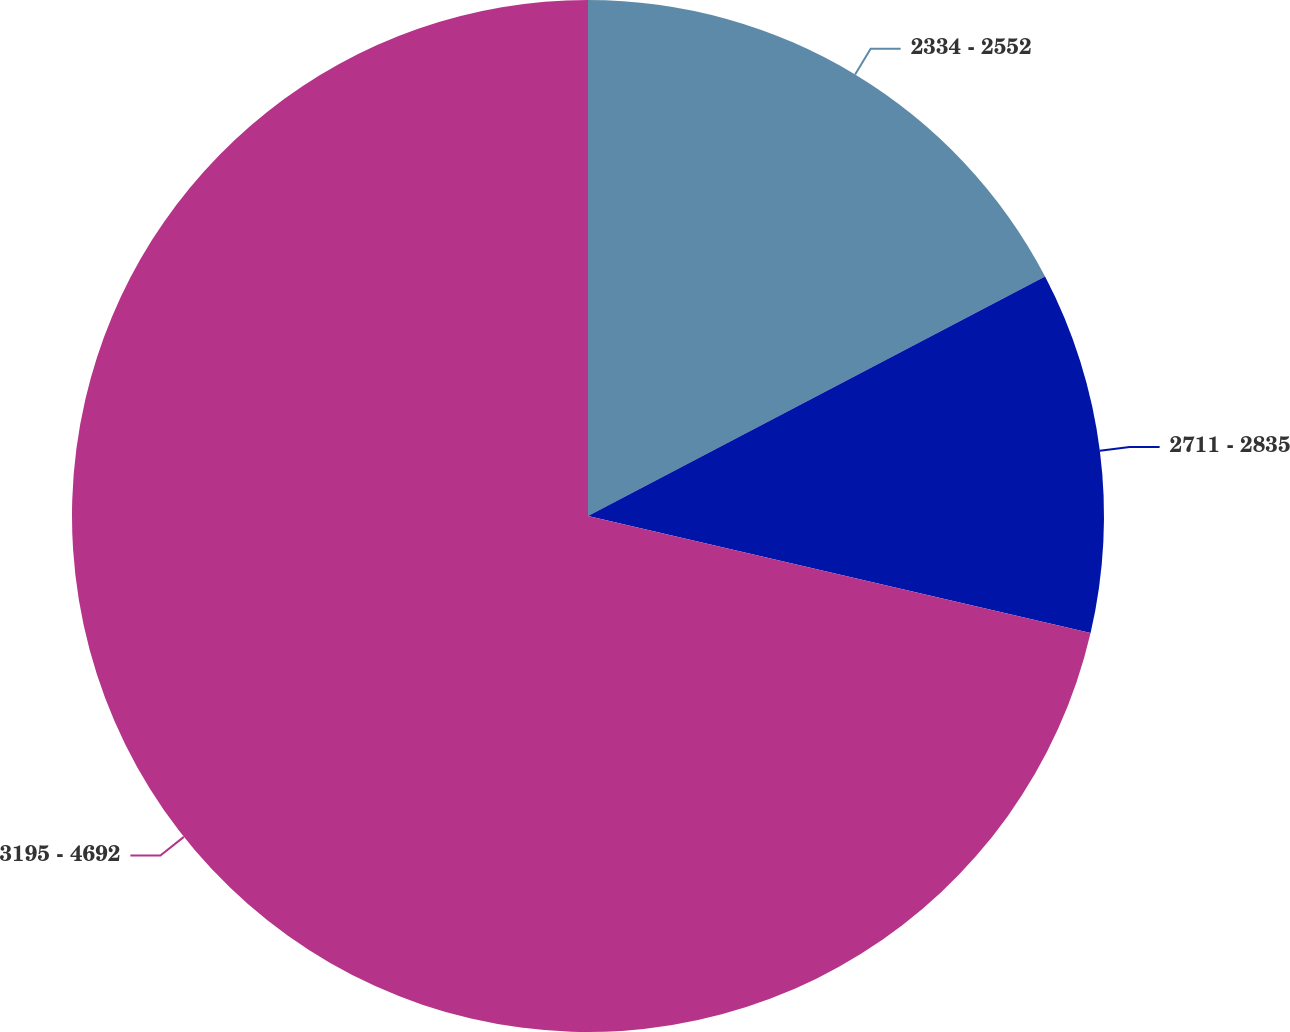Convert chart. <chart><loc_0><loc_0><loc_500><loc_500><pie_chart><fcel>2334 - 2552<fcel>2711 - 2835<fcel>3195 - 4692<nl><fcel>17.32%<fcel>11.32%<fcel>71.36%<nl></chart> 